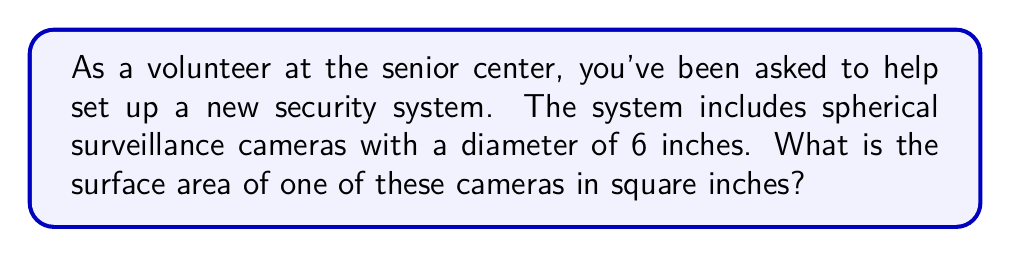Teach me how to tackle this problem. Let's approach this step-by-step:

1) The formula for the surface area of a sphere is:
   $$A = 4\pi r^2$$
   where $A$ is the surface area and $r$ is the radius of the sphere.

2) We're given the diameter of 6 inches. The radius is half of the diameter:
   $$r = \frac{6}{2} = 3\text{ inches}$$

3) Now, let's substitute this into our formula:
   $$A = 4\pi (3)^2$$

4) Simplify:
   $$A = 4\pi (9) = 36\pi$$

5) If we want to calculate the exact value:
   $$A = 36\pi \approx 113.10\text{ square inches}$$

[asy]
import geometry;

size(100);
draw(circle((0,0),3), blue);
draw((0,0)--(3,0), arrow=Arrow(TeXHead));
label("r=3", (1.5,0.5));
label("d=6", (-1,-3.5));
draw((-3,0)--(3,0), dashed);
[/asy]
Answer: $36\pi$ square inches (or approximately 113.10 square inches) 